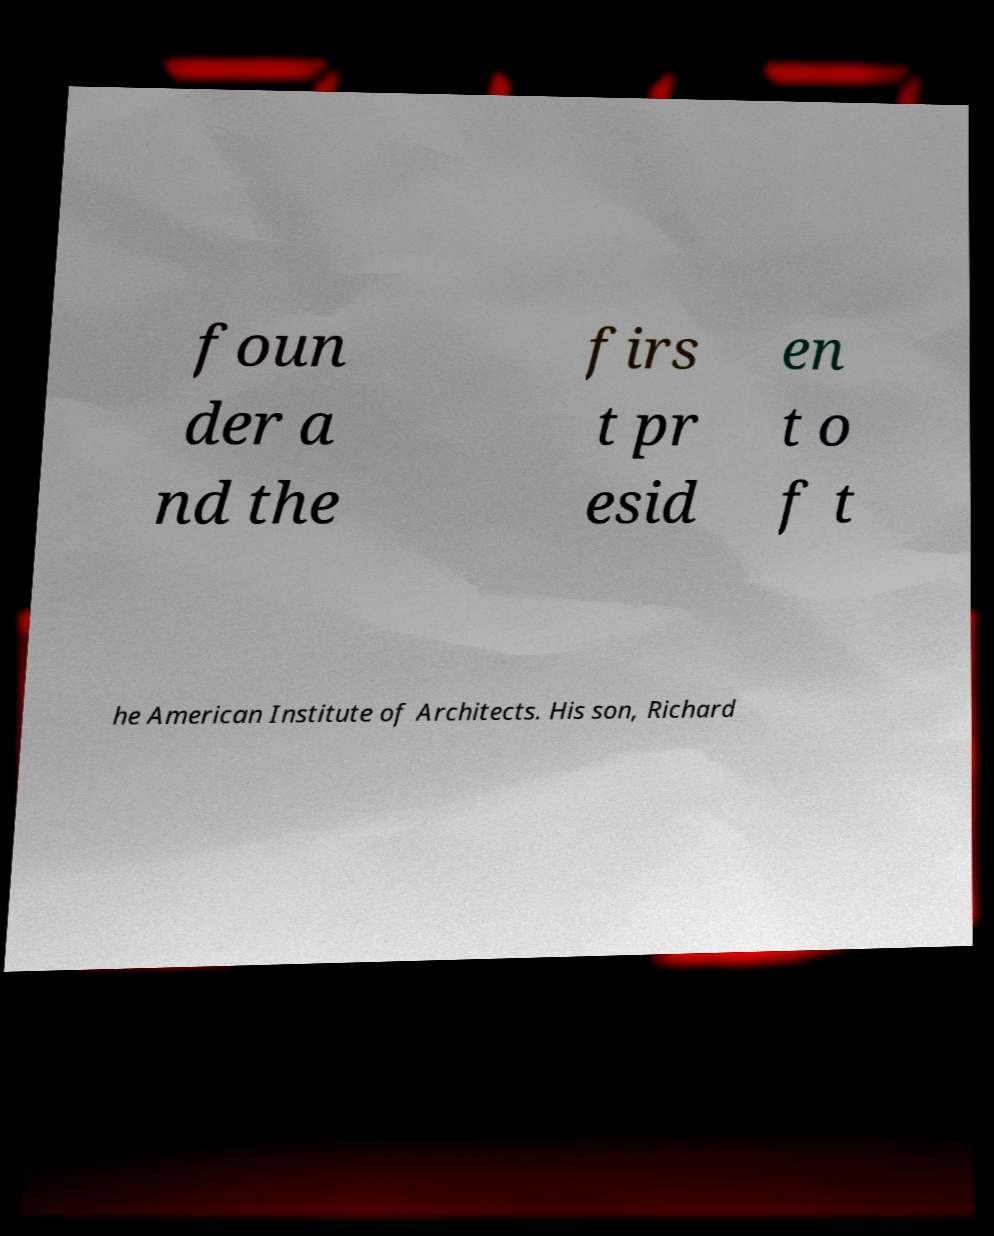What messages or text are displayed in this image? I need them in a readable, typed format. foun der a nd the firs t pr esid en t o f t he American Institute of Architects. His son, Richard 